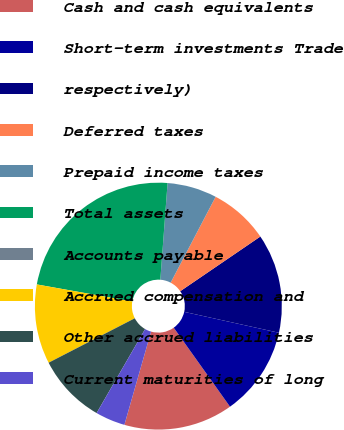Convert chart. <chart><loc_0><loc_0><loc_500><loc_500><pie_chart><fcel>Cash and cash equivalents<fcel>Short-term investments Trade<fcel>respectively)<fcel>Deferred taxes<fcel>Prepaid income taxes<fcel>Total assets<fcel>Accounts payable<fcel>Accrued compensation and<fcel>Other accrued liabilities<fcel>Current maturities of long<nl><fcel>14.29%<fcel>11.69%<fcel>12.99%<fcel>7.79%<fcel>6.49%<fcel>23.38%<fcel>0.0%<fcel>10.39%<fcel>9.09%<fcel>3.9%<nl></chart> 